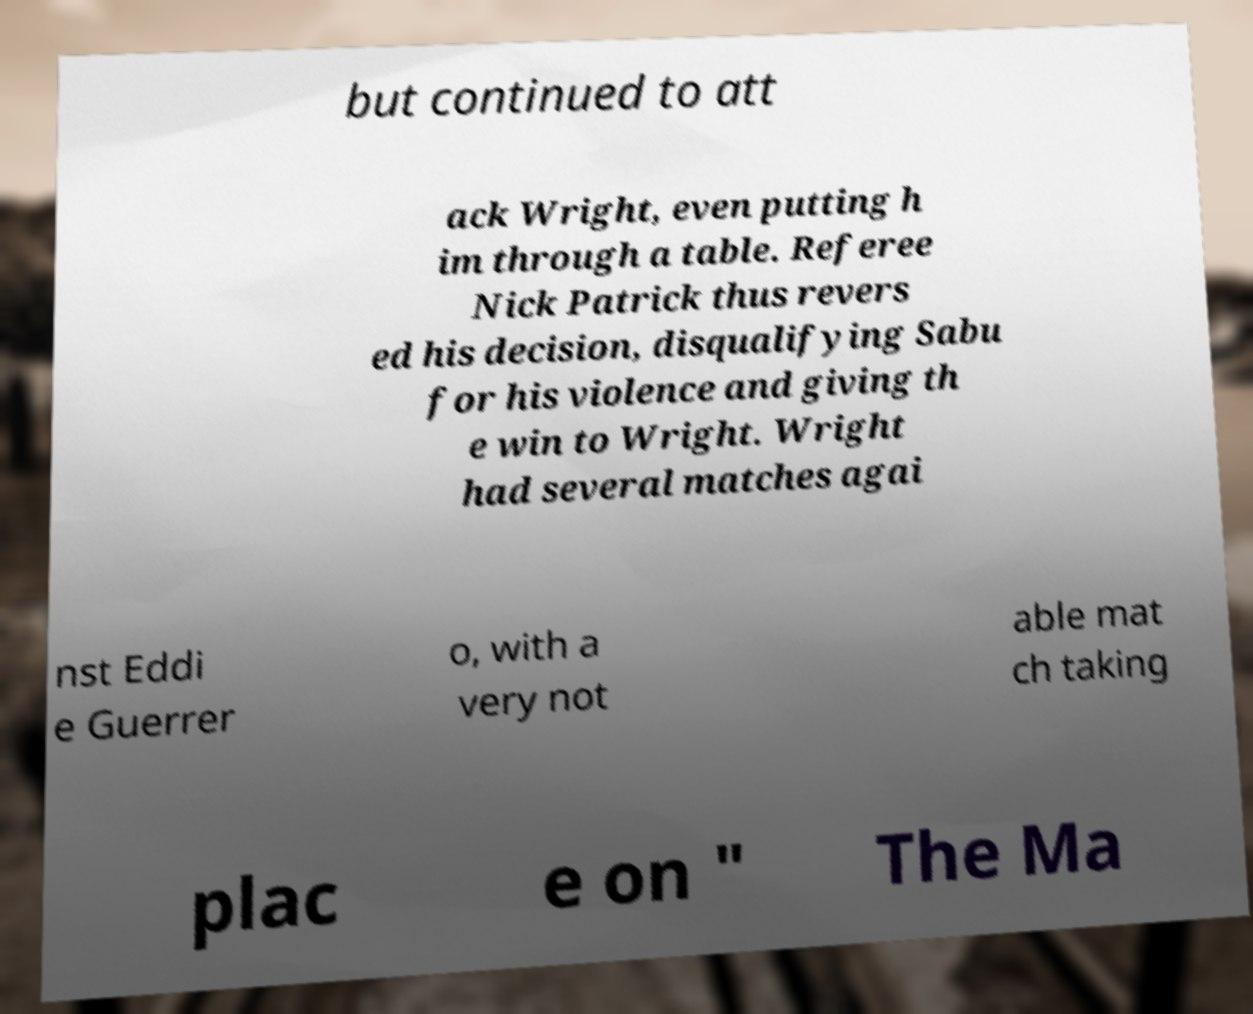Please read and relay the text visible in this image. What does it say? but continued to att ack Wright, even putting h im through a table. Referee Nick Patrick thus revers ed his decision, disqualifying Sabu for his violence and giving th e win to Wright. Wright had several matches agai nst Eddi e Guerrer o, with a very not able mat ch taking plac e on " The Ma 